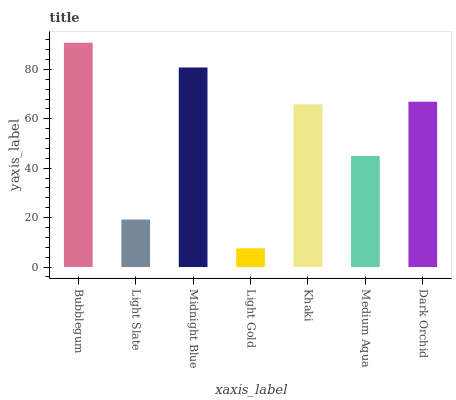Is Light Gold the minimum?
Answer yes or no. Yes. Is Bubblegum the maximum?
Answer yes or no. Yes. Is Light Slate the minimum?
Answer yes or no. No. Is Light Slate the maximum?
Answer yes or no. No. Is Bubblegum greater than Light Slate?
Answer yes or no. Yes. Is Light Slate less than Bubblegum?
Answer yes or no. Yes. Is Light Slate greater than Bubblegum?
Answer yes or no. No. Is Bubblegum less than Light Slate?
Answer yes or no. No. Is Khaki the high median?
Answer yes or no. Yes. Is Khaki the low median?
Answer yes or no. Yes. Is Dark Orchid the high median?
Answer yes or no. No. Is Midnight Blue the low median?
Answer yes or no. No. 